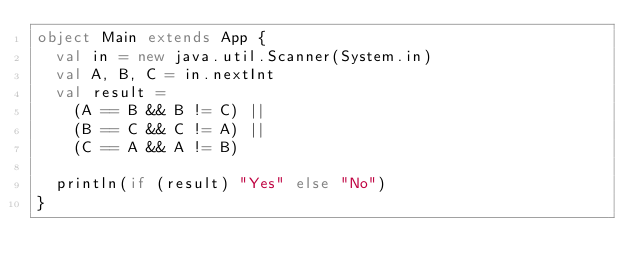<code> <loc_0><loc_0><loc_500><loc_500><_Scala_>object Main extends App {
  val in = new java.util.Scanner(System.in)
  val A, B, C = in.nextInt
  val result =
    (A == B && B != C) ||
    (B == C && C != A) ||
    (C == A && A != B)

  println(if (result) "Yes" else "No")
}</code> 